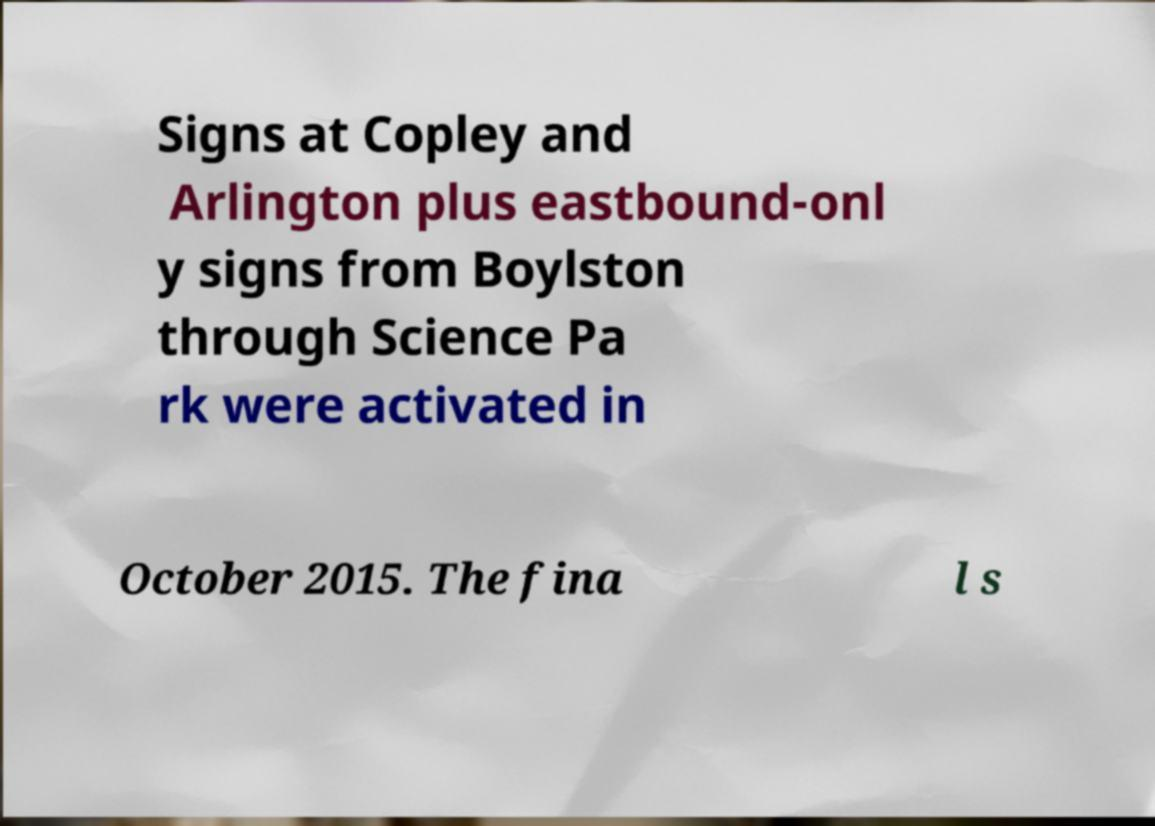Please identify and transcribe the text found in this image. Signs at Copley and Arlington plus eastbound-onl y signs from Boylston through Science Pa rk were activated in October 2015. The fina l s 